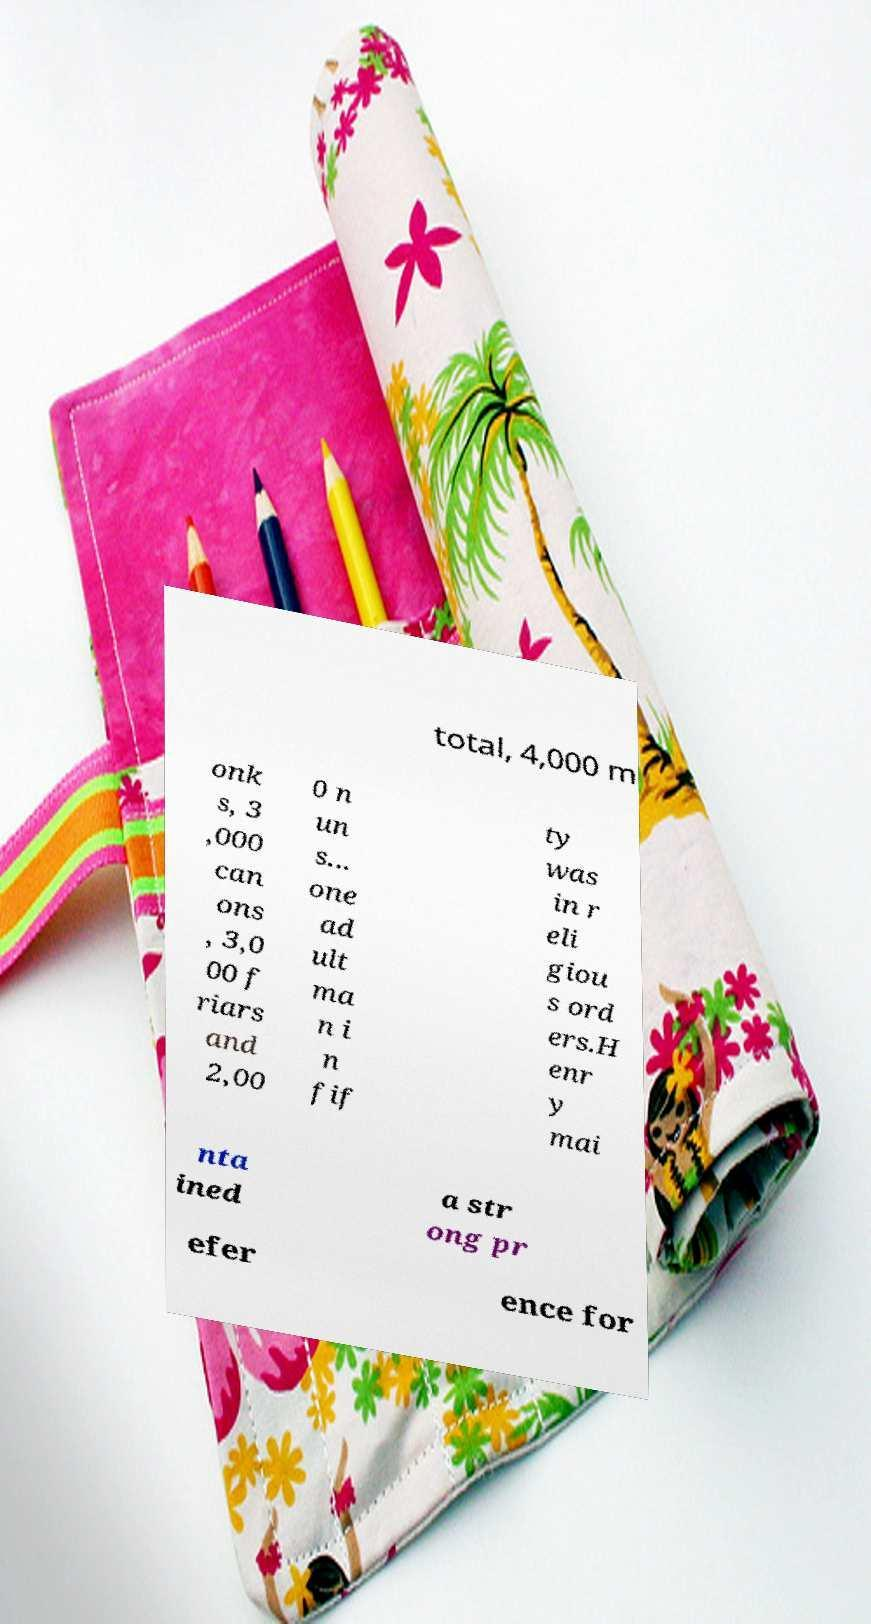For documentation purposes, I need the text within this image transcribed. Could you provide that? total, 4,000 m onk s, 3 ,000 can ons , 3,0 00 f riars and 2,00 0 n un s... one ad ult ma n i n fif ty was in r eli giou s ord ers.H enr y mai nta ined a str ong pr efer ence for 